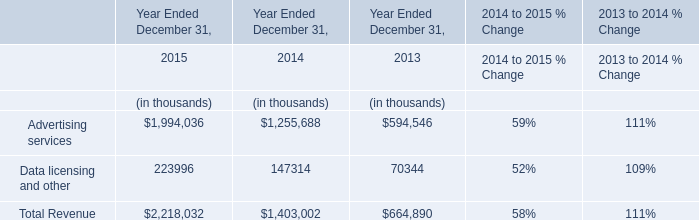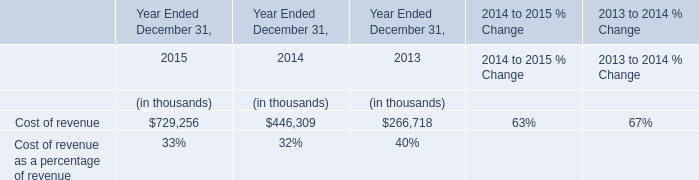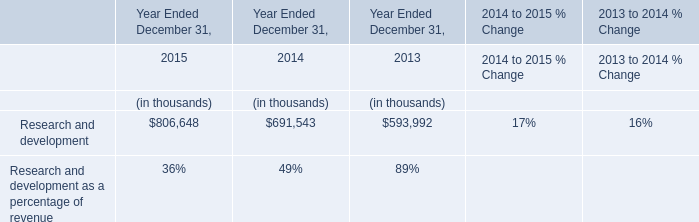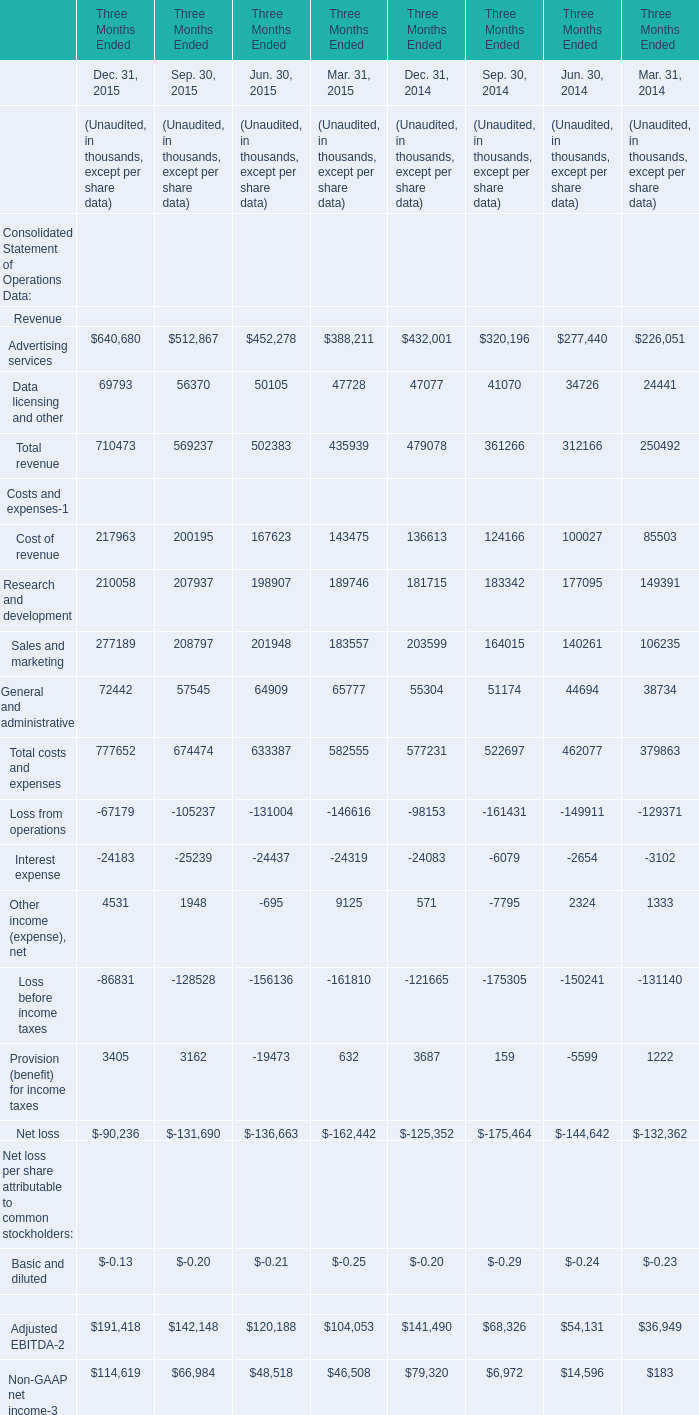Which year is Cost of revenue for Sep. 30 greater than 200000? 
Answer: 2015. 